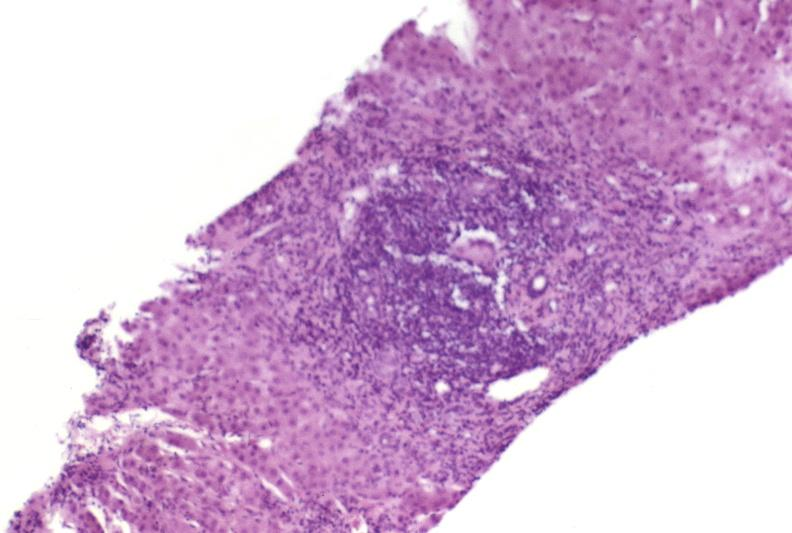what does this image show?
Answer the question using a single word or phrase. Autoimmune hepatitis 